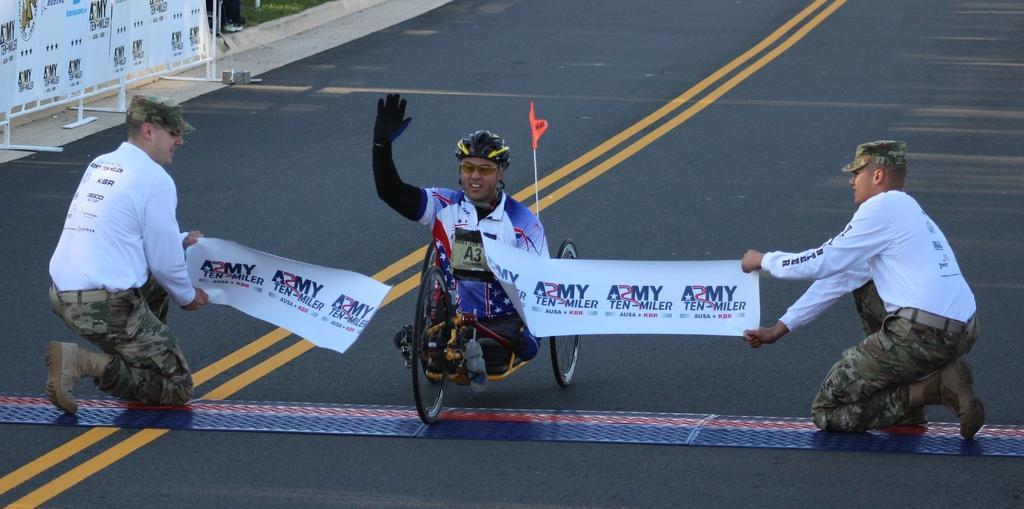Describe this image in one or two sentences. In this image I can see a person sitting on bi-cycle and there are two persons sitting in squat position holding a pump- let visible on road, there is a stand and hoarding board visible in the top left. 